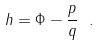<formula> <loc_0><loc_0><loc_500><loc_500>h = \Phi - \frac { p } { q } \ .</formula> 